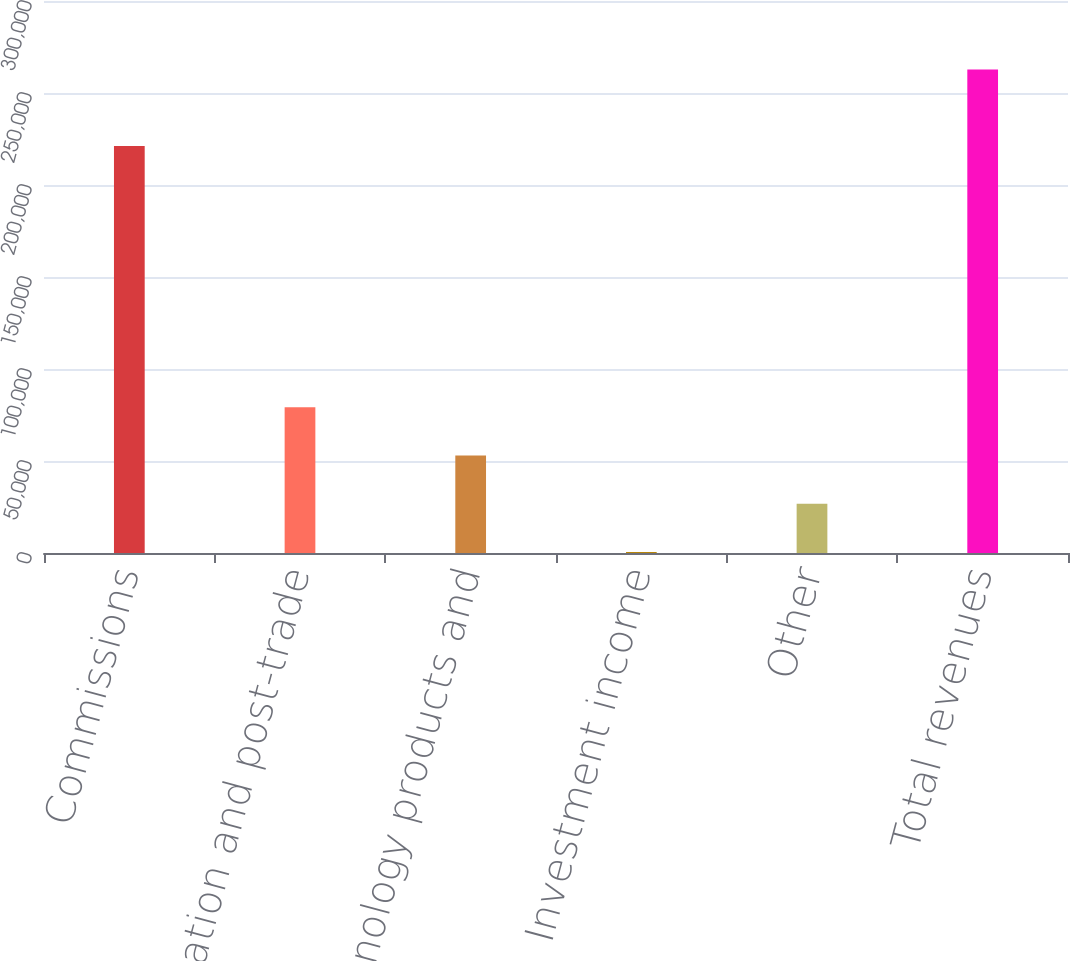<chart> <loc_0><loc_0><loc_500><loc_500><bar_chart><fcel>Commissions<fcel>Information and post-trade<fcel>Technology products and<fcel>Investment income<fcel>Other<fcel>Total revenues<nl><fcel>221138<fcel>79212.3<fcel>52989.2<fcel>543<fcel>26766.1<fcel>262774<nl></chart> 